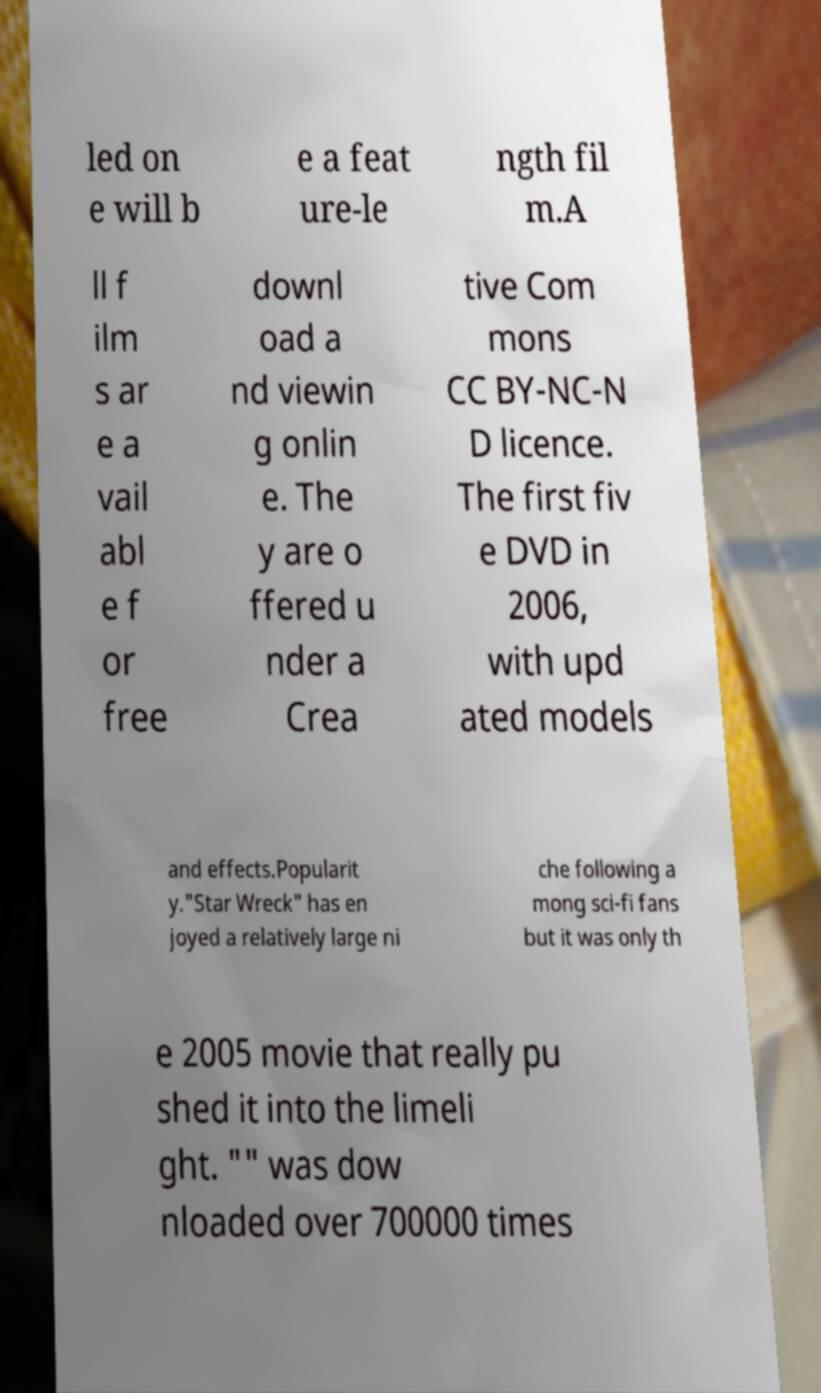Please identify and transcribe the text found in this image. led on e will b e a feat ure-le ngth fil m.A ll f ilm s ar e a vail abl e f or free downl oad a nd viewin g onlin e. The y are o ffered u nder a Crea tive Com mons CC BY-NC-N D licence. The first fiv e DVD in 2006, with upd ated models and effects.Popularit y."Star Wreck" has en joyed a relatively large ni che following a mong sci-fi fans but it was only th e 2005 movie that really pu shed it into the limeli ght. "" was dow nloaded over 700000 times 